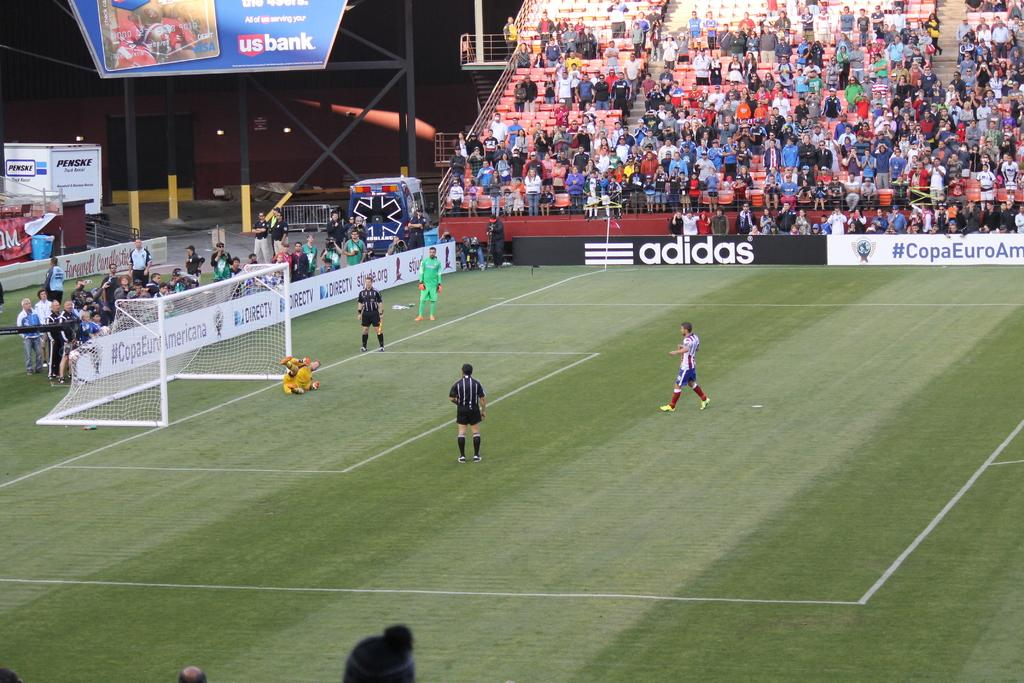Provide a one-sentence caption for the provided image. A soccer field with an adidas advertisement in the back. 